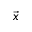Convert formula to latex. <formula><loc_0><loc_0><loc_500><loc_500>\vec { x }</formula> 